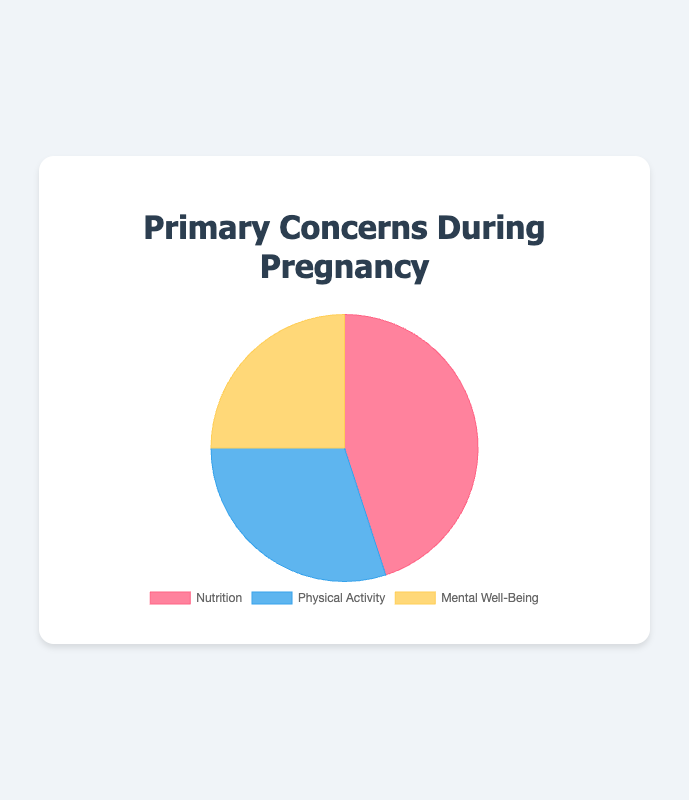What percentage of people are primarily concerned with Physical Activity during pregnancy? First, identify the portion labeled "Physical Activity" on the pie chart. The percentage given for this section is 30%.
Answer: 30% Which concern during pregnancy has the highest percentage? Compare the different sections of the pie chart. The section with the highest percentage is "Nutrition" at 45%.
Answer: Nutrition What is the combined percentage of people primarily concerned with Nutrition and Mental Well-Being? Add the percentages for "Nutrition" and "Mental Well-Being": 45% + 25% = 70%.
Answer: 70% How much greater is the concern for Nutrition compared to Mental Well-Being? Subtract the percentage of Mental Well-Being from Nutrition: 45% - 25% = 20%.
Answer: 20% Which visual segment represents the concern with the smallest percentage, and what is this percentage? Identify the smallest section of the pie chart; it is "Mental Well-Being", which is labeled with 25%.
Answer: Mental Well-Being, 25% What is the difference in percentage between the primary concerns for Physical Activity and Mental Well-Being? Subtract the percentage of Mental Well-Being from Physical Activity: 30% - 25% = 5%.
Answer: 5% Is the combined percentage of Physical Activity and Mental Well-Being greater or smaller than the percentage for Nutrition? Add the percentages for Physical Activity and Mental Well-Being first: 30% + 25% = 55%. Compare this to the 45% for Nutrition. 55% is greater than 45%.
Answer: Greater Which concern is represented by the blue section of the pie chart? Look for the section colored blue, which corresponds to the label "Physical Activity".
Answer: Physical Activity What is the overall difference in percentage between the highest and the lowest primary concerns during pregnancy? Subtract the lowest percentage (Mental Well-Being, 25%) from the highest percentage (Nutrition, 45%): 45% - 25% = 20%.
Answer: 20% What proportion of the pie chart is represented by concerns other than Nutrition? Subtract the percentage for Nutrition from 100%: 100% - 45% = 55%.
Answer: 55% 